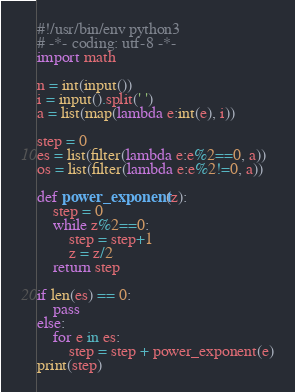Convert code to text. <code><loc_0><loc_0><loc_500><loc_500><_Python_>#!/usr/bin/env python3
# -*- coding: utf-8 -*-
import math

n = int(input())
i = input().split(' ')
a = list(map(lambda e:int(e), i))

step = 0
es = list(filter(lambda e:e%2==0, a))
os = list(filter(lambda e:e%2!=0, a))

def power_exponent(z):
    step = 0
    while z%2==0:
        step = step+1
        z = z/2
    return step

if len(es) == 0:
    pass
else:
    for e in es:
        step = step + power_exponent(e)
print(step)
</code> 